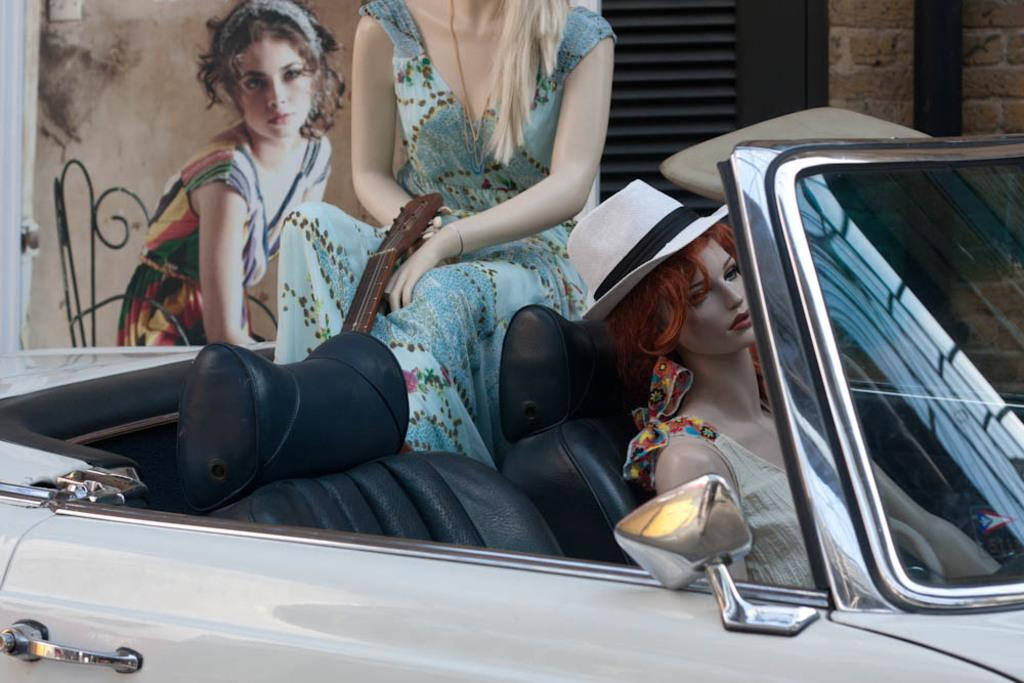What objects can be seen inside the car in the image? There are dolls and a guitar in the car. What is present on the wall in the image? There is a picture of a woman on a wall. What is the woman in the picture doing? The woman in the picture is sitting on a chair. How many slaves are visible in the image? There are no slaves present in the image. What action is the woman in the picture performing? The woman in the picture is sitting on a chair, not performing any action. 